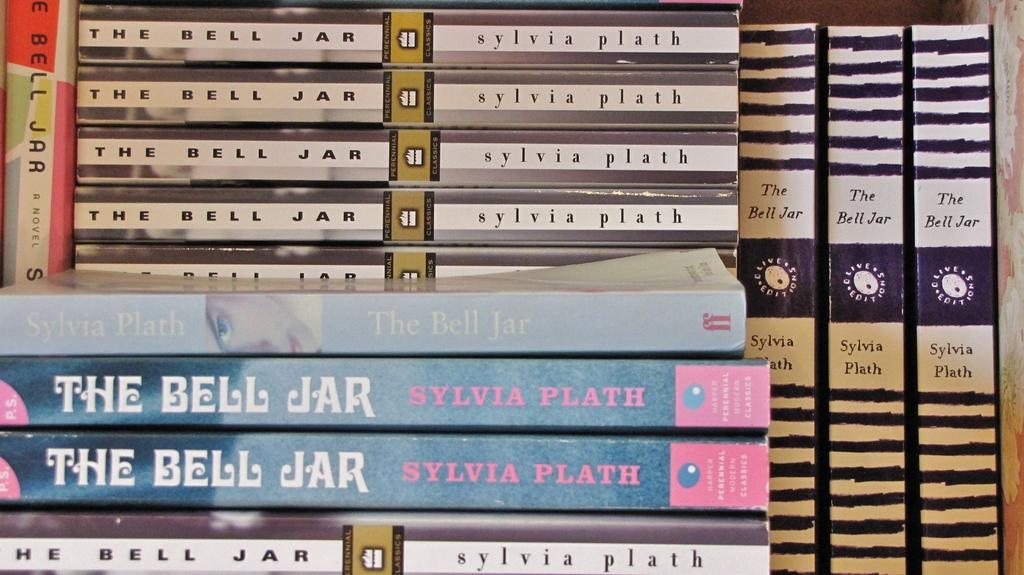Provide a one-sentence caption for the provided image. Many different copies of The Bell Jar by Sylvia Plath. 